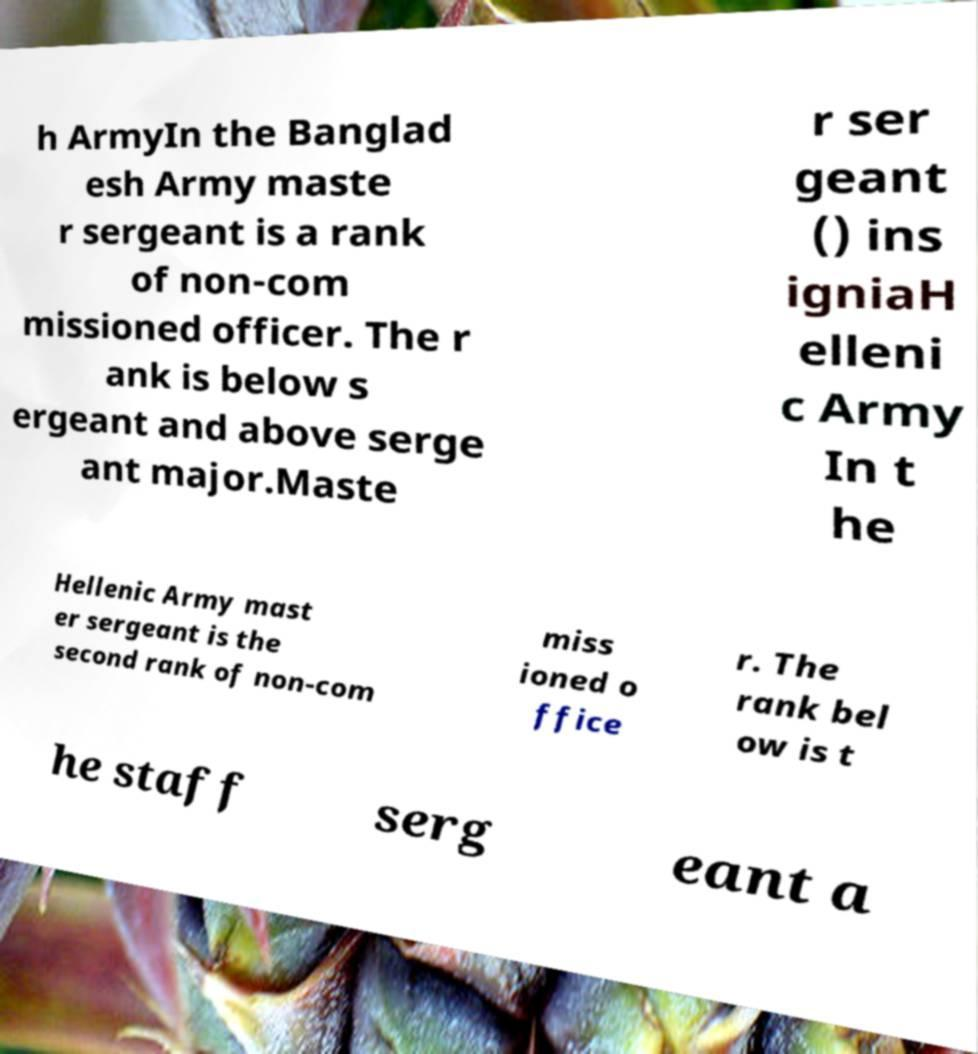Please identify and transcribe the text found in this image. h ArmyIn the Banglad esh Army maste r sergeant is a rank of non-com missioned officer. The r ank is below s ergeant and above serge ant major.Maste r ser geant () ins igniaH elleni c Army In t he Hellenic Army mast er sergeant is the second rank of non-com miss ioned o ffice r. The rank bel ow is t he staff serg eant a 